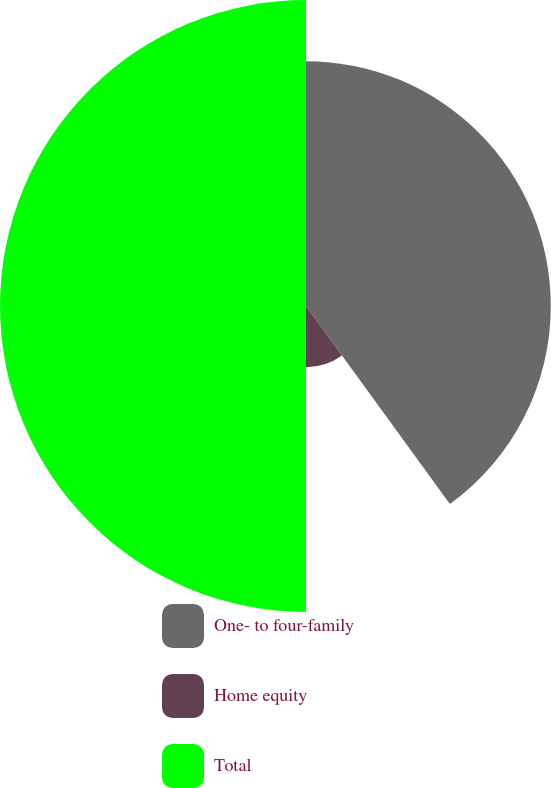Convert chart. <chart><loc_0><loc_0><loc_500><loc_500><pie_chart><fcel>One- to four-family<fcel>Home equity<fcel>Total<nl><fcel>40.0%<fcel>10.0%<fcel>50.0%<nl></chart> 